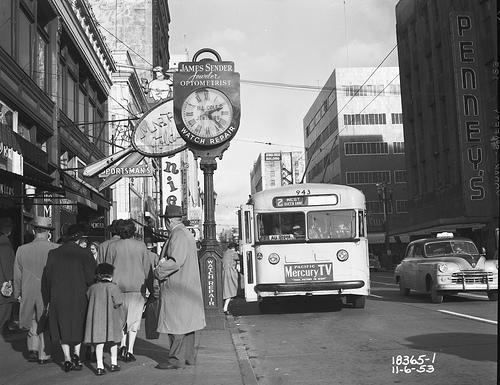Is there a bus in the picture?
Write a very short answer. Yes. What is the date for this photograph?
Give a very brief answer. 11-6-53. Is the picture colorful?
Quick response, please. No. 